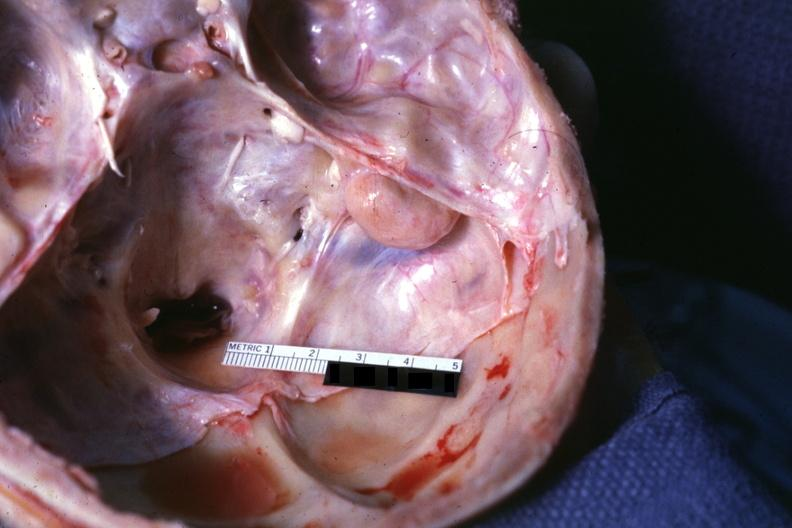does this image show opened base of skull with brain removed?
Answer the question using a single word or phrase. Yes 